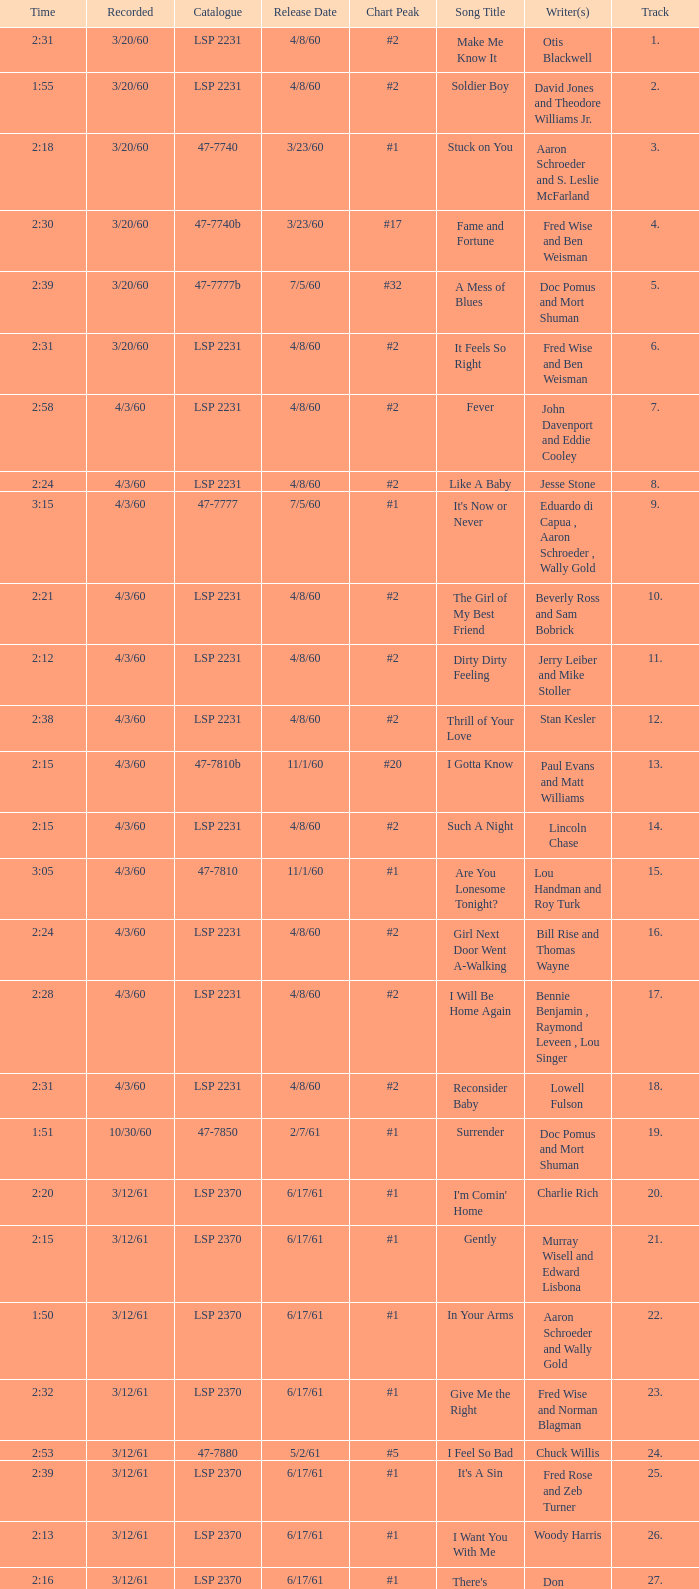Parse the table in full. {'header': ['Time', 'Recorded', 'Catalogue', 'Release Date', 'Chart Peak', 'Song Title', 'Writer(s)', 'Track'], 'rows': [['2:31', '3/20/60', 'LSP 2231', '4/8/60', '#2', 'Make Me Know It', 'Otis Blackwell', '1.'], ['1:55', '3/20/60', 'LSP 2231', '4/8/60', '#2', 'Soldier Boy', 'David Jones and Theodore Williams Jr.', '2.'], ['2:18', '3/20/60', '47-7740', '3/23/60', '#1', 'Stuck on You', 'Aaron Schroeder and S. Leslie McFarland', '3.'], ['2:30', '3/20/60', '47-7740b', '3/23/60', '#17', 'Fame and Fortune', 'Fred Wise and Ben Weisman', '4.'], ['2:39', '3/20/60', '47-7777b', '7/5/60', '#32', 'A Mess of Blues', 'Doc Pomus and Mort Shuman', '5.'], ['2:31', '3/20/60', 'LSP 2231', '4/8/60', '#2', 'It Feels So Right', 'Fred Wise and Ben Weisman', '6.'], ['2:58', '4/3/60', 'LSP 2231', '4/8/60', '#2', 'Fever', 'John Davenport and Eddie Cooley', '7.'], ['2:24', '4/3/60', 'LSP 2231', '4/8/60', '#2', 'Like A Baby', 'Jesse Stone', '8.'], ['3:15', '4/3/60', '47-7777', '7/5/60', '#1', "It's Now or Never", 'Eduardo di Capua , Aaron Schroeder , Wally Gold', '9.'], ['2:21', '4/3/60', 'LSP 2231', '4/8/60', '#2', 'The Girl of My Best Friend', 'Beverly Ross and Sam Bobrick', '10.'], ['2:12', '4/3/60', 'LSP 2231', '4/8/60', '#2', 'Dirty Dirty Feeling', 'Jerry Leiber and Mike Stoller', '11.'], ['2:38', '4/3/60', 'LSP 2231', '4/8/60', '#2', 'Thrill of Your Love', 'Stan Kesler', '12.'], ['2:15', '4/3/60', '47-7810b', '11/1/60', '#20', 'I Gotta Know', 'Paul Evans and Matt Williams', '13.'], ['2:15', '4/3/60', 'LSP 2231', '4/8/60', '#2', 'Such A Night', 'Lincoln Chase', '14.'], ['3:05', '4/3/60', '47-7810', '11/1/60', '#1', 'Are You Lonesome Tonight?', 'Lou Handman and Roy Turk', '15.'], ['2:24', '4/3/60', 'LSP 2231', '4/8/60', '#2', 'Girl Next Door Went A-Walking', 'Bill Rise and Thomas Wayne', '16.'], ['2:28', '4/3/60', 'LSP 2231', '4/8/60', '#2', 'I Will Be Home Again', 'Bennie Benjamin , Raymond Leveen , Lou Singer', '17.'], ['2:31', '4/3/60', 'LSP 2231', '4/8/60', '#2', 'Reconsider Baby', 'Lowell Fulson', '18.'], ['1:51', '10/30/60', '47-7850', '2/7/61', '#1', 'Surrender', 'Doc Pomus and Mort Shuman', '19.'], ['2:20', '3/12/61', 'LSP 2370', '6/17/61', '#1', "I'm Comin' Home", 'Charlie Rich', '20.'], ['2:15', '3/12/61', 'LSP 2370', '6/17/61', '#1', 'Gently', 'Murray Wisell and Edward Lisbona', '21.'], ['1:50', '3/12/61', 'LSP 2370', '6/17/61', '#1', 'In Your Arms', 'Aaron Schroeder and Wally Gold', '22.'], ['2:32', '3/12/61', 'LSP 2370', '6/17/61', '#1', 'Give Me the Right', 'Fred Wise and Norman Blagman', '23.'], ['2:53', '3/12/61', '47-7880', '5/2/61', '#5', 'I Feel So Bad', 'Chuck Willis', '24.'], ['2:39', '3/12/61', 'LSP 2370', '6/17/61', '#1', "It's A Sin", 'Fred Rose and Zeb Turner', '25.'], ['2:13', '3/12/61', 'LSP 2370', '6/17/61', '#1', 'I Want You With Me', 'Woody Harris', '26.'], ['2:16', '3/12/61', 'LSP 2370', '6/17/61', '#1', "There's Always Me", 'Don Robertson', '27.']]} What catalogue is the song It's Now or Never? 47-7777. 